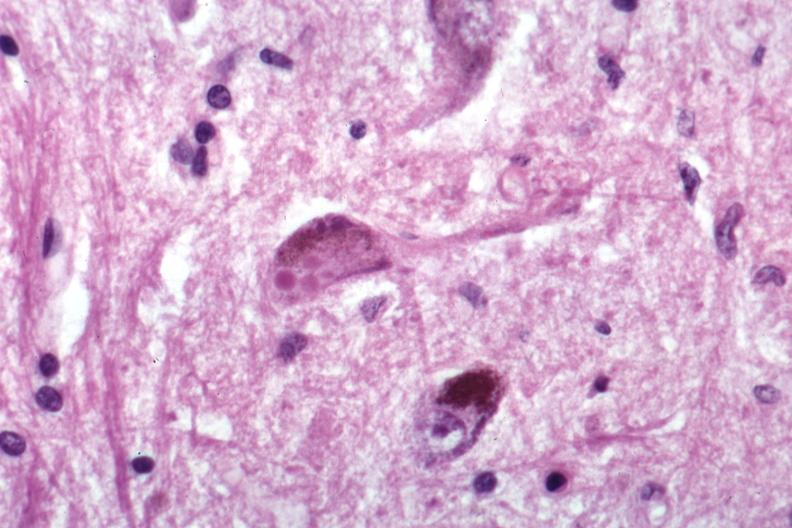s neurofibrillary change present?
Answer the question using a single word or phrase. No 